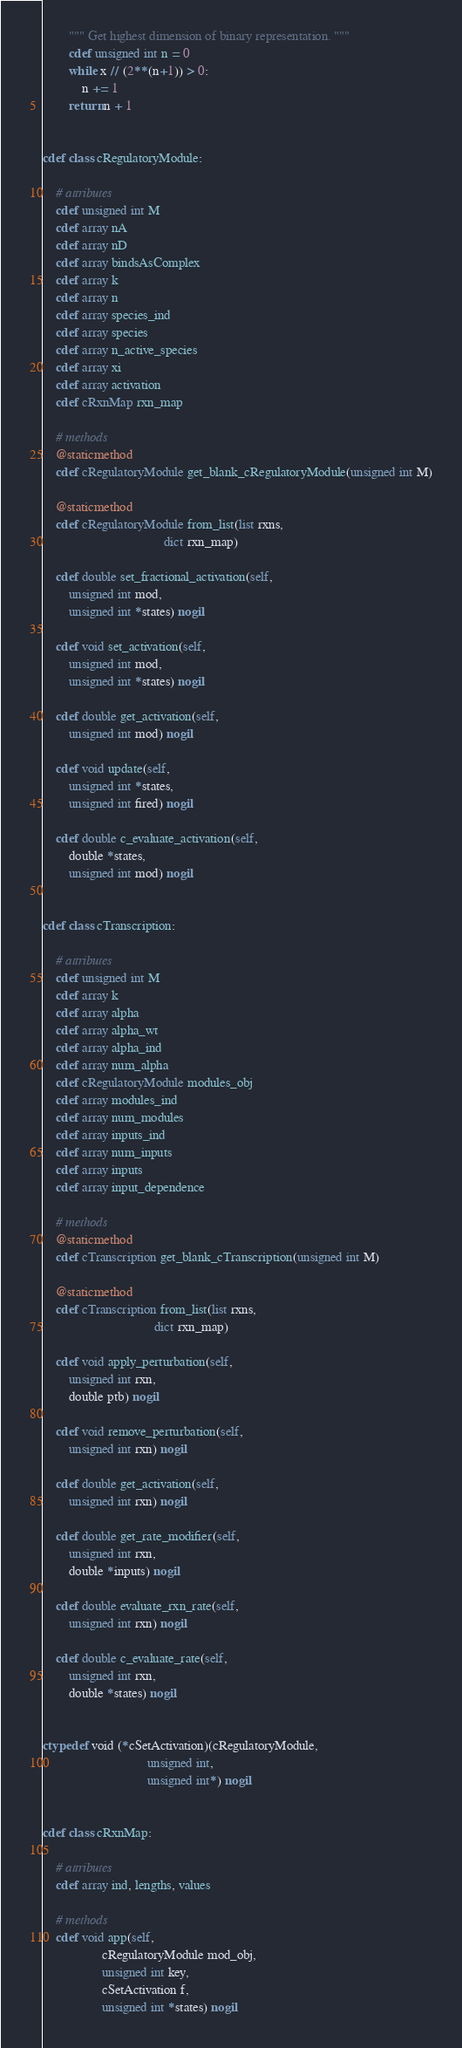<code> <loc_0><loc_0><loc_500><loc_500><_Cython_>        """ Get highest dimension of binary representation. """
        cdef unsigned int n = 0
        while x // (2**(n+1)) > 0:
            n += 1
        return n + 1


cdef class cRegulatoryModule:

    # attributes
    cdef unsigned int M
    cdef array nA
    cdef array nD
    cdef array bindsAsComplex
    cdef array k
    cdef array n
    cdef array species_ind
    cdef array species
    cdef array n_active_species
    cdef array xi
    cdef array activation
    cdef cRxnMap rxn_map

    # methods
    @staticmethod
    cdef cRegulatoryModule get_blank_cRegulatoryModule(unsigned int M)

    @staticmethod
    cdef cRegulatoryModule from_list(list rxns,
                                     dict rxn_map)

    cdef double set_fractional_activation(self,
        unsigned int mod,
        unsigned int *states) nogil

    cdef void set_activation(self,
        unsigned int mod,
        unsigned int *states) nogil

    cdef double get_activation(self,
        unsigned int mod) nogil

    cdef void update(self,
        unsigned int *states,
        unsigned int fired) nogil

    cdef double c_evaluate_activation(self,
        double *states,
        unsigned int mod) nogil


cdef class cTranscription:

    # attributes
    cdef unsigned int M
    cdef array k
    cdef array alpha
    cdef array alpha_wt
    cdef array alpha_ind
    cdef array num_alpha
    cdef cRegulatoryModule modules_obj
    cdef array modules_ind
    cdef array num_modules
    cdef array inputs_ind
    cdef array num_inputs
    cdef array inputs
    cdef array input_dependence

    # methods
    @staticmethod
    cdef cTranscription get_blank_cTranscription(unsigned int M)

    @staticmethod
    cdef cTranscription from_list(list rxns,
                                  dict rxn_map)

    cdef void apply_perturbation(self,
        unsigned int rxn,
        double ptb) nogil

    cdef void remove_perturbation(self,
        unsigned int rxn) nogil

    cdef double get_activation(self,
        unsigned int rxn) nogil

    cdef double get_rate_modifier(self,
        unsigned int rxn,
        double *inputs) nogil

    cdef double evaluate_rxn_rate(self,
        unsigned int rxn) nogil

    cdef double c_evaluate_rate(self,
        unsigned int rxn,
        double *states) nogil


ctypedef void (*cSetActivation)(cRegulatoryModule,
                                unsigned int,
                                unsigned int*) nogil


cdef class cRxnMap:

    # attributes
    cdef array ind, lengths, values

    # methods
    cdef void app(self,
                  cRegulatoryModule mod_obj,
                  unsigned int key,
                  cSetActivation f,
                  unsigned int *states) nogil
</code> 